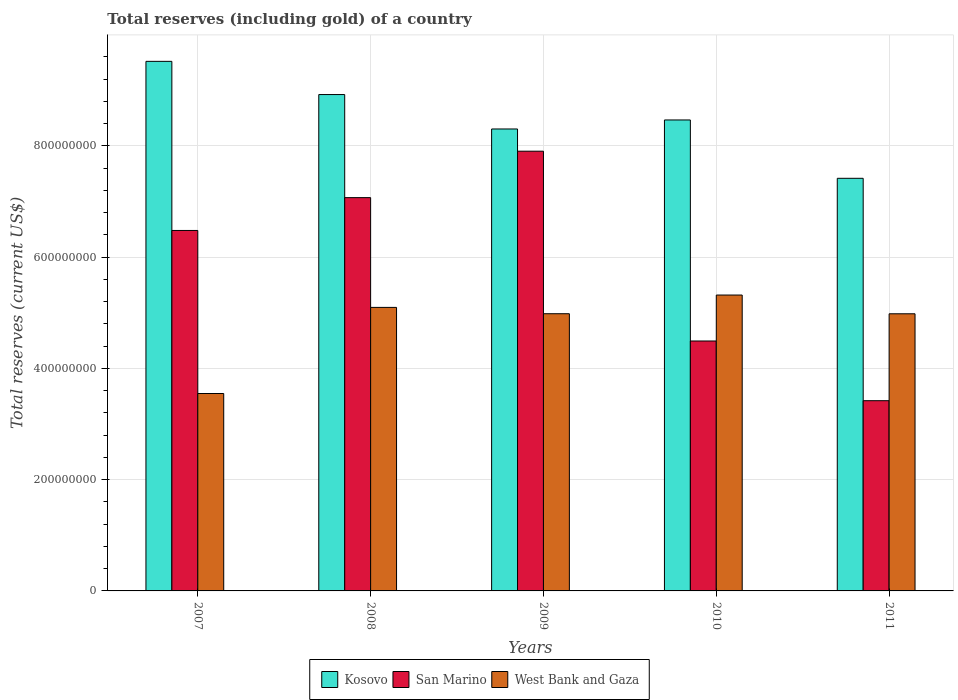How many different coloured bars are there?
Your response must be concise. 3. How many groups of bars are there?
Make the answer very short. 5. Are the number of bars per tick equal to the number of legend labels?
Your response must be concise. Yes. How many bars are there on the 3rd tick from the right?
Provide a succinct answer. 3. What is the label of the 4th group of bars from the left?
Provide a succinct answer. 2010. In how many cases, is the number of bars for a given year not equal to the number of legend labels?
Make the answer very short. 0. What is the total reserves (including gold) in San Marino in 2007?
Provide a short and direct response. 6.48e+08. Across all years, what is the maximum total reserves (including gold) in San Marino?
Your response must be concise. 7.90e+08. Across all years, what is the minimum total reserves (including gold) in West Bank and Gaza?
Keep it short and to the point. 3.55e+08. In which year was the total reserves (including gold) in West Bank and Gaza maximum?
Your answer should be compact. 2010. What is the total total reserves (including gold) in San Marino in the graph?
Provide a short and direct response. 2.94e+09. What is the difference between the total reserves (including gold) in Kosovo in 2007 and that in 2010?
Make the answer very short. 1.05e+08. What is the difference between the total reserves (including gold) in Kosovo in 2011 and the total reserves (including gold) in West Bank and Gaza in 2008?
Make the answer very short. 2.32e+08. What is the average total reserves (including gold) in San Marino per year?
Provide a short and direct response. 5.87e+08. In the year 2007, what is the difference between the total reserves (including gold) in San Marino and total reserves (including gold) in West Bank and Gaza?
Ensure brevity in your answer.  2.93e+08. In how many years, is the total reserves (including gold) in Kosovo greater than 480000000 US$?
Offer a terse response. 5. What is the ratio of the total reserves (including gold) in San Marino in 2007 to that in 2008?
Give a very brief answer. 0.92. Is the total reserves (including gold) in San Marino in 2008 less than that in 2010?
Your response must be concise. No. Is the difference between the total reserves (including gold) in San Marino in 2008 and 2010 greater than the difference between the total reserves (including gold) in West Bank and Gaza in 2008 and 2010?
Ensure brevity in your answer.  Yes. What is the difference between the highest and the second highest total reserves (including gold) in Kosovo?
Ensure brevity in your answer.  5.97e+07. What is the difference between the highest and the lowest total reserves (including gold) in San Marino?
Offer a very short reply. 4.48e+08. In how many years, is the total reserves (including gold) in Kosovo greater than the average total reserves (including gold) in Kosovo taken over all years?
Provide a succinct answer. 2. Is the sum of the total reserves (including gold) in Kosovo in 2010 and 2011 greater than the maximum total reserves (including gold) in San Marino across all years?
Provide a succinct answer. Yes. What does the 1st bar from the left in 2007 represents?
Your response must be concise. Kosovo. What does the 1st bar from the right in 2011 represents?
Ensure brevity in your answer.  West Bank and Gaza. Are all the bars in the graph horizontal?
Your answer should be compact. No. What is the difference between two consecutive major ticks on the Y-axis?
Ensure brevity in your answer.  2.00e+08. Does the graph contain any zero values?
Your answer should be very brief. No. Does the graph contain grids?
Keep it short and to the point. Yes. How many legend labels are there?
Keep it short and to the point. 3. How are the legend labels stacked?
Your answer should be very brief. Horizontal. What is the title of the graph?
Offer a terse response. Total reserves (including gold) of a country. What is the label or title of the X-axis?
Ensure brevity in your answer.  Years. What is the label or title of the Y-axis?
Your answer should be compact. Total reserves (current US$). What is the Total reserves (current US$) of Kosovo in 2007?
Your answer should be compact. 9.52e+08. What is the Total reserves (current US$) in San Marino in 2007?
Keep it short and to the point. 6.48e+08. What is the Total reserves (current US$) in West Bank and Gaza in 2007?
Your answer should be very brief. 3.55e+08. What is the Total reserves (current US$) of Kosovo in 2008?
Keep it short and to the point. 8.92e+08. What is the Total reserves (current US$) of San Marino in 2008?
Offer a terse response. 7.07e+08. What is the Total reserves (current US$) of West Bank and Gaza in 2008?
Ensure brevity in your answer.  5.10e+08. What is the Total reserves (current US$) in Kosovo in 2009?
Provide a succinct answer. 8.30e+08. What is the Total reserves (current US$) of San Marino in 2009?
Offer a very short reply. 7.90e+08. What is the Total reserves (current US$) of West Bank and Gaza in 2009?
Make the answer very short. 4.98e+08. What is the Total reserves (current US$) in Kosovo in 2010?
Your answer should be compact. 8.46e+08. What is the Total reserves (current US$) of San Marino in 2010?
Keep it short and to the point. 4.49e+08. What is the Total reserves (current US$) of West Bank and Gaza in 2010?
Your answer should be compact. 5.32e+08. What is the Total reserves (current US$) of Kosovo in 2011?
Offer a terse response. 7.42e+08. What is the Total reserves (current US$) in San Marino in 2011?
Provide a succinct answer. 3.42e+08. What is the Total reserves (current US$) of West Bank and Gaza in 2011?
Provide a succinct answer. 4.98e+08. Across all years, what is the maximum Total reserves (current US$) of Kosovo?
Make the answer very short. 9.52e+08. Across all years, what is the maximum Total reserves (current US$) in San Marino?
Your response must be concise. 7.90e+08. Across all years, what is the maximum Total reserves (current US$) in West Bank and Gaza?
Offer a very short reply. 5.32e+08. Across all years, what is the minimum Total reserves (current US$) in Kosovo?
Your answer should be very brief. 7.42e+08. Across all years, what is the minimum Total reserves (current US$) in San Marino?
Your answer should be compact. 3.42e+08. Across all years, what is the minimum Total reserves (current US$) in West Bank and Gaza?
Offer a very short reply. 3.55e+08. What is the total Total reserves (current US$) of Kosovo in the graph?
Your answer should be very brief. 4.26e+09. What is the total Total reserves (current US$) of San Marino in the graph?
Make the answer very short. 2.94e+09. What is the total Total reserves (current US$) in West Bank and Gaza in the graph?
Ensure brevity in your answer.  2.39e+09. What is the difference between the Total reserves (current US$) of Kosovo in 2007 and that in 2008?
Offer a very short reply. 5.97e+07. What is the difference between the Total reserves (current US$) in San Marino in 2007 and that in 2008?
Your response must be concise. -5.90e+07. What is the difference between the Total reserves (current US$) of West Bank and Gaza in 2007 and that in 2008?
Provide a short and direct response. -1.55e+08. What is the difference between the Total reserves (current US$) of Kosovo in 2007 and that in 2009?
Your answer should be very brief. 1.22e+08. What is the difference between the Total reserves (current US$) in San Marino in 2007 and that in 2009?
Ensure brevity in your answer.  -1.42e+08. What is the difference between the Total reserves (current US$) of West Bank and Gaza in 2007 and that in 2009?
Keep it short and to the point. -1.43e+08. What is the difference between the Total reserves (current US$) in Kosovo in 2007 and that in 2010?
Provide a short and direct response. 1.05e+08. What is the difference between the Total reserves (current US$) in San Marino in 2007 and that in 2010?
Keep it short and to the point. 1.99e+08. What is the difference between the Total reserves (current US$) in West Bank and Gaza in 2007 and that in 2010?
Ensure brevity in your answer.  -1.77e+08. What is the difference between the Total reserves (current US$) of Kosovo in 2007 and that in 2011?
Provide a succinct answer. 2.10e+08. What is the difference between the Total reserves (current US$) in San Marino in 2007 and that in 2011?
Make the answer very short. 3.06e+08. What is the difference between the Total reserves (current US$) in West Bank and Gaza in 2007 and that in 2011?
Your answer should be very brief. -1.43e+08. What is the difference between the Total reserves (current US$) in Kosovo in 2008 and that in 2009?
Offer a very short reply. 6.19e+07. What is the difference between the Total reserves (current US$) of San Marino in 2008 and that in 2009?
Keep it short and to the point. -8.35e+07. What is the difference between the Total reserves (current US$) in West Bank and Gaza in 2008 and that in 2009?
Make the answer very short. 1.14e+07. What is the difference between the Total reserves (current US$) in Kosovo in 2008 and that in 2010?
Your answer should be very brief. 4.57e+07. What is the difference between the Total reserves (current US$) of San Marino in 2008 and that in 2010?
Ensure brevity in your answer.  2.58e+08. What is the difference between the Total reserves (current US$) of West Bank and Gaza in 2008 and that in 2010?
Provide a short and direct response. -2.22e+07. What is the difference between the Total reserves (current US$) of Kosovo in 2008 and that in 2011?
Give a very brief answer. 1.51e+08. What is the difference between the Total reserves (current US$) of San Marino in 2008 and that in 2011?
Your answer should be very brief. 3.65e+08. What is the difference between the Total reserves (current US$) in West Bank and Gaza in 2008 and that in 2011?
Make the answer very short. 1.15e+07. What is the difference between the Total reserves (current US$) in Kosovo in 2009 and that in 2010?
Offer a very short reply. -1.62e+07. What is the difference between the Total reserves (current US$) of San Marino in 2009 and that in 2010?
Your response must be concise. 3.41e+08. What is the difference between the Total reserves (current US$) in West Bank and Gaza in 2009 and that in 2010?
Offer a very short reply. -3.36e+07. What is the difference between the Total reserves (current US$) of Kosovo in 2009 and that in 2011?
Make the answer very short. 8.87e+07. What is the difference between the Total reserves (current US$) of San Marino in 2009 and that in 2011?
Provide a short and direct response. 4.48e+08. What is the difference between the Total reserves (current US$) in West Bank and Gaza in 2009 and that in 2011?
Provide a short and direct response. 1.26e+05. What is the difference between the Total reserves (current US$) of Kosovo in 2010 and that in 2011?
Your answer should be very brief. 1.05e+08. What is the difference between the Total reserves (current US$) in San Marino in 2010 and that in 2011?
Ensure brevity in your answer.  1.07e+08. What is the difference between the Total reserves (current US$) of West Bank and Gaza in 2010 and that in 2011?
Offer a terse response. 3.37e+07. What is the difference between the Total reserves (current US$) of Kosovo in 2007 and the Total reserves (current US$) of San Marino in 2008?
Your answer should be compact. 2.45e+08. What is the difference between the Total reserves (current US$) of Kosovo in 2007 and the Total reserves (current US$) of West Bank and Gaza in 2008?
Offer a very short reply. 4.42e+08. What is the difference between the Total reserves (current US$) of San Marino in 2007 and the Total reserves (current US$) of West Bank and Gaza in 2008?
Your answer should be very brief. 1.38e+08. What is the difference between the Total reserves (current US$) in Kosovo in 2007 and the Total reserves (current US$) in San Marino in 2009?
Keep it short and to the point. 1.61e+08. What is the difference between the Total reserves (current US$) in Kosovo in 2007 and the Total reserves (current US$) in West Bank and Gaza in 2009?
Ensure brevity in your answer.  4.54e+08. What is the difference between the Total reserves (current US$) of San Marino in 2007 and the Total reserves (current US$) of West Bank and Gaza in 2009?
Provide a short and direct response. 1.50e+08. What is the difference between the Total reserves (current US$) of Kosovo in 2007 and the Total reserves (current US$) of San Marino in 2010?
Offer a very short reply. 5.03e+08. What is the difference between the Total reserves (current US$) in Kosovo in 2007 and the Total reserves (current US$) in West Bank and Gaza in 2010?
Offer a terse response. 4.20e+08. What is the difference between the Total reserves (current US$) in San Marino in 2007 and the Total reserves (current US$) in West Bank and Gaza in 2010?
Your response must be concise. 1.16e+08. What is the difference between the Total reserves (current US$) in Kosovo in 2007 and the Total reserves (current US$) in San Marino in 2011?
Provide a short and direct response. 6.10e+08. What is the difference between the Total reserves (current US$) in Kosovo in 2007 and the Total reserves (current US$) in West Bank and Gaza in 2011?
Your answer should be compact. 4.54e+08. What is the difference between the Total reserves (current US$) of San Marino in 2007 and the Total reserves (current US$) of West Bank and Gaza in 2011?
Give a very brief answer. 1.50e+08. What is the difference between the Total reserves (current US$) in Kosovo in 2008 and the Total reserves (current US$) in San Marino in 2009?
Offer a terse response. 1.02e+08. What is the difference between the Total reserves (current US$) in Kosovo in 2008 and the Total reserves (current US$) in West Bank and Gaza in 2009?
Ensure brevity in your answer.  3.94e+08. What is the difference between the Total reserves (current US$) in San Marino in 2008 and the Total reserves (current US$) in West Bank and Gaza in 2009?
Your answer should be compact. 2.09e+08. What is the difference between the Total reserves (current US$) of Kosovo in 2008 and the Total reserves (current US$) of San Marino in 2010?
Give a very brief answer. 4.43e+08. What is the difference between the Total reserves (current US$) in Kosovo in 2008 and the Total reserves (current US$) in West Bank and Gaza in 2010?
Your response must be concise. 3.60e+08. What is the difference between the Total reserves (current US$) of San Marino in 2008 and the Total reserves (current US$) of West Bank and Gaza in 2010?
Offer a terse response. 1.75e+08. What is the difference between the Total reserves (current US$) in Kosovo in 2008 and the Total reserves (current US$) in San Marino in 2011?
Give a very brief answer. 5.50e+08. What is the difference between the Total reserves (current US$) in Kosovo in 2008 and the Total reserves (current US$) in West Bank and Gaza in 2011?
Offer a very short reply. 3.94e+08. What is the difference between the Total reserves (current US$) of San Marino in 2008 and the Total reserves (current US$) of West Bank and Gaza in 2011?
Provide a succinct answer. 2.09e+08. What is the difference between the Total reserves (current US$) of Kosovo in 2009 and the Total reserves (current US$) of San Marino in 2010?
Give a very brief answer. 3.81e+08. What is the difference between the Total reserves (current US$) in Kosovo in 2009 and the Total reserves (current US$) in West Bank and Gaza in 2010?
Keep it short and to the point. 2.98e+08. What is the difference between the Total reserves (current US$) in San Marino in 2009 and the Total reserves (current US$) in West Bank and Gaza in 2010?
Make the answer very short. 2.59e+08. What is the difference between the Total reserves (current US$) in Kosovo in 2009 and the Total reserves (current US$) in San Marino in 2011?
Your answer should be compact. 4.88e+08. What is the difference between the Total reserves (current US$) in Kosovo in 2009 and the Total reserves (current US$) in West Bank and Gaza in 2011?
Your response must be concise. 3.32e+08. What is the difference between the Total reserves (current US$) in San Marino in 2009 and the Total reserves (current US$) in West Bank and Gaza in 2011?
Your response must be concise. 2.92e+08. What is the difference between the Total reserves (current US$) of Kosovo in 2010 and the Total reserves (current US$) of San Marino in 2011?
Keep it short and to the point. 5.05e+08. What is the difference between the Total reserves (current US$) in Kosovo in 2010 and the Total reserves (current US$) in West Bank and Gaza in 2011?
Your answer should be compact. 3.48e+08. What is the difference between the Total reserves (current US$) of San Marino in 2010 and the Total reserves (current US$) of West Bank and Gaza in 2011?
Offer a terse response. -4.89e+07. What is the average Total reserves (current US$) of Kosovo per year?
Your answer should be very brief. 8.52e+08. What is the average Total reserves (current US$) in San Marino per year?
Offer a terse response. 5.87e+08. What is the average Total reserves (current US$) of West Bank and Gaza per year?
Make the answer very short. 4.78e+08. In the year 2007, what is the difference between the Total reserves (current US$) of Kosovo and Total reserves (current US$) of San Marino?
Offer a very short reply. 3.04e+08. In the year 2007, what is the difference between the Total reserves (current US$) in Kosovo and Total reserves (current US$) in West Bank and Gaza?
Your answer should be compact. 5.97e+08. In the year 2007, what is the difference between the Total reserves (current US$) of San Marino and Total reserves (current US$) of West Bank and Gaza?
Offer a very short reply. 2.93e+08. In the year 2008, what is the difference between the Total reserves (current US$) of Kosovo and Total reserves (current US$) of San Marino?
Offer a very short reply. 1.85e+08. In the year 2008, what is the difference between the Total reserves (current US$) in Kosovo and Total reserves (current US$) in West Bank and Gaza?
Your answer should be compact. 3.83e+08. In the year 2008, what is the difference between the Total reserves (current US$) in San Marino and Total reserves (current US$) in West Bank and Gaza?
Your answer should be very brief. 1.97e+08. In the year 2009, what is the difference between the Total reserves (current US$) in Kosovo and Total reserves (current US$) in San Marino?
Provide a succinct answer. 3.99e+07. In the year 2009, what is the difference between the Total reserves (current US$) in Kosovo and Total reserves (current US$) in West Bank and Gaza?
Ensure brevity in your answer.  3.32e+08. In the year 2009, what is the difference between the Total reserves (current US$) in San Marino and Total reserves (current US$) in West Bank and Gaza?
Your answer should be very brief. 2.92e+08. In the year 2010, what is the difference between the Total reserves (current US$) in Kosovo and Total reserves (current US$) in San Marino?
Keep it short and to the point. 3.97e+08. In the year 2010, what is the difference between the Total reserves (current US$) in Kosovo and Total reserves (current US$) in West Bank and Gaza?
Ensure brevity in your answer.  3.15e+08. In the year 2010, what is the difference between the Total reserves (current US$) in San Marino and Total reserves (current US$) in West Bank and Gaza?
Provide a succinct answer. -8.26e+07. In the year 2011, what is the difference between the Total reserves (current US$) in Kosovo and Total reserves (current US$) in San Marino?
Make the answer very short. 4.00e+08. In the year 2011, what is the difference between the Total reserves (current US$) in Kosovo and Total reserves (current US$) in West Bank and Gaza?
Provide a succinct answer. 2.43e+08. In the year 2011, what is the difference between the Total reserves (current US$) in San Marino and Total reserves (current US$) in West Bank and Gaza?
Offer a very short reply. -1.56e+08. What is the ratio of the Total reserves (current US$) in Kosovo in 2007 to that in 2008?
Give a very brief answer. 1.07. What is the ratio of the Total reserves (current US$) in San Marino in 2007 to that in 2008?
Keep it short and to the point. 0.92. What is the ratio of the Total reserves (current US$) in West Bank and Gaza in 2007 to that in 2008?
Your answer should be compact. 0.7. What is the ratio of the Total reserves (current US$) in Kosovo in 2007 to that in 2009?
Make the answer very short. 1.15. What is the ratio of the Total reserves (current US$) in San Marino in 2007 to that in 2009?
Provide a succinct answer. 0.82. What is the ratio of the Total reserves (current US$) in West Bank and Gaza in 2007 to that in 2009?
Offer a terse response. 0.71. What is the ratio of the Total reserves (current US$) of Kosovo in 2007 to that in 2010?
Your answer should be very brief. 1.12. What is the ratio of the Total reserves (current US$) of San Marino in 2007 to that in 2010?
Offer a very short reply. 1.44. What is the ratio of the Total reserves (current US$) in West Bank and Gaza in 2007 to that in 2010?
Offer a very short reply. 0.67. What is the ratio of the Total reserves (current US$) of Kosovo in 2007 to that in 2011?
Ensure brevity in your answer.  1.28. What is the ratio of the Total reserves (current US$) in San Marino in 2007 to that in 2011?
Offer a very short reply. 1.89. What is the ratio of the Total reserves (current US$) in West Bank and Gaza in 2007 to that in 2011?
Offer a very short reply. 0.71. What is the ratio of the Total reserves (current US$) in Kosovo in 2008 to that in 2009?
Provide a short and direct response. 1.07. What is the ratio of the Total reserves (current US$) in San Marino in 2008 to that in 2009?
Ensure brevity in your answer.  0.89. What is the ratio of the Total reserves (current US$) of West Bank and Gaza in 2008 to that in 2009?
Provide a short and direct response. 1.02. What is the ratio of the Total reserves (current US$) of Kosovo in 2008 to that in 2010?
Offer a terse response. 1.05. What is the ratio of the Total reserves (current US$) in San Marino in 2008 to that in 2010?
Your answer should be compact. 1.57. What is the ratio of the Total reserves (current US$) in West Bank and Gaza in 2008 to that in 2010?
Offer a very short reply. 0.96. What is the ratio of the Total reserves (current US$) in Kosovo in 2008 to that in 2011?
Provide a succinct answer. 1.2. What is the ratio of the Total reserves (current US$) of San Marino in 2008 to that in 2011?
Make the answer very short. 2.07. What is the ratio of the Total reserves (current US$) of West Bank and Gaza in 2008 to that in 2011?
Keep it short and to the point. 1.02. What is the ratio of the Total reserves (current US$) in Kosovo in 2009 to that in 2010?
Offer a terse response. 0.98. What is the ratio of the Total reserves (current US$) in San Marino in 2009 to that in 2010?
Ensure brevity in your answer.  1.76. What is the ratio of the Total reserves (current US$) of West Bank and Gaza in 2009 to that in 2010?
Offer a terse response. 0.94. What is the ratio of the Total reserves (current US$) in Kosovo in 2009 to that in 2011?
Ensure brevity in your answer.  1.12. What is the ratio of the Total reserves (current US$) of San Marino in 2009 to that in 2011?
Offer a terse response. 2.31. What is the ratio of the Total reserves (current US$) in Kosovo in 2010 to that in 2011?
Provide a succinct answer. 1.14. What is the ratio of the Total reserves (current US$) of San Marino in 2010 to that in 2011?
Offer a very short reply. 1.31. What is the ratio of the Total reserves (current US$) in West Bank and Gaza in 2010 to that in 2011?
Offer a very short reply. 1.07. What is the difference between the highest and the second highest Total reserves (current US$) in Kosovo?
Ensure brevity in your answer.  5.97e+07. What is the difference between the highest and the second highest Total reserves (current US$) in San Marino?
Your answer should be compact. 8.35e+07. What is the difference between the highest and the second highest Total reserves (current US$) in West Bank and Gaza?
Keep it short and to the point. 2.22e+07. What is the difference between the highest and the lowest Total reserves (current US$) in Kosovo?
Your answer should be very brief. 2.10e+08. What is the difference between the highest and the lowest Total reserves (current US$) of San Marino?
Keep it short and to the point. 4.48e+08. What is the difference between the highest and the lowest Total reserves (current US$) in West Bank and Gaza?
Your answer should be compact. 1.77e+08. 